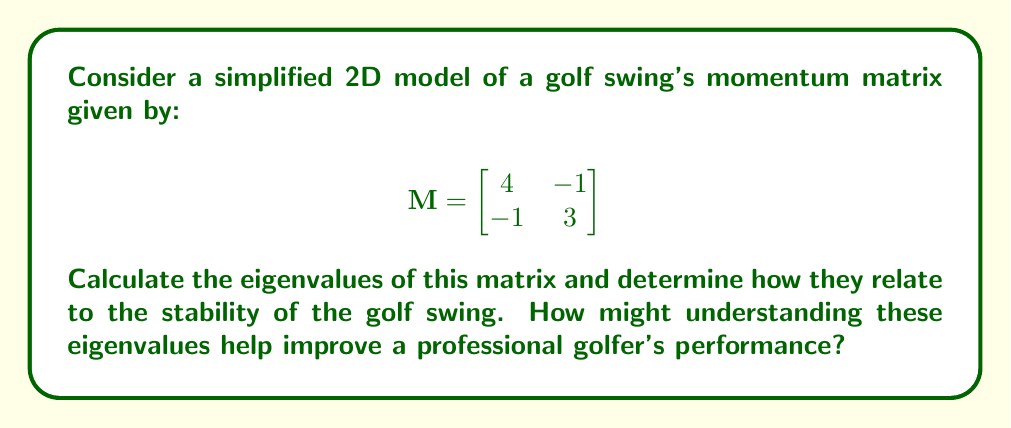Give your solution to this math problem. To find the eigenvalues of the momentum matrix M, we need to solve the characteristic equation:

1) $\det(M - \lambda I) = 0$, where $I$ is the 2x2 identity matrix.

2) Expanding this, we get:
   $$\begin{vmatrix}
   4-\lambda & -1 \\
   -1 & 3-\lambda
   \end{vmatrix} = 0$$

3) $(4-\lambda)(3-\lambda) - (-1)(-1) = 0$

4) $\lambda^2 - 7\lambda + 11 = 0$

5) Using the quadratic formula, $\lambda = \frac{-b \pm \sqrt{b^2-4ac}}{2a}$:
   $$\lambda = \frac{7 \pm \sqrt{49-44}}{2} = \frac{7 \pm \sqrt{5}}{2}$$

6) Therefore, the eigenvalues are:
   $$\lambda_1 = \frac{7 + \sqrt{5}}{2} \approx 4.618$$
   $$\lambda_2 = \frac{7 - \sqrt{5}}{2} \approx 2.382$$

7) Both eigenvalues are positive and real, indicating a stable system. The larger eigenvalue ($\lambda_1$) represents the principal direction of momentum in the swing, while the smaller eigenvalue ($\lambda_2$) represents a secondary, less dominant direction.

8) For a professional golfer, understanding these eigenvalues can help in the following ways:
   a) The ratio of eigenvalues ($\lambda_1 / \lambda_2$) indicates how much more dominant the principal direction is compared to the secondary direction. A higher ratio suggests a more consistent, "cleaner" swing.
   b) The magnitude of $\lambda_1$ relates to the overall power of the swing.
   c) Adjusting technique to increase $\lambda_1$ while maintaining or decreasing $\lambda_2$ could lead to more powerful, consistent swings.

By analyzing and optimizing these eigenvalues through practice and technique refinement, a professional golfer could potentially improve their swing stability, power, and consistency, leading to better performance in championships.
Answer: $\lambda_1 = \frac{7 + \sqrt{5}}{2}, \lambda_2 = \frac{7 - \sqrt{5}}{2}$ 